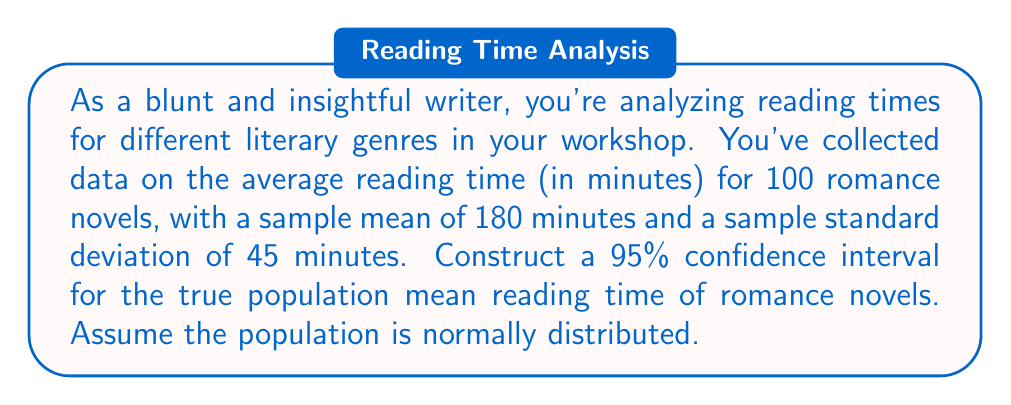Show me your answer to this math problem. To construct a confidence interval for the population mean, we'll use the t-distribution since we don't know the population standard deviation. Here's the step-by-step process:

1. Identify the given information:
   - Sample size: $n = 100$
   - Sample mean: $\bar{x} = 180$ minutes
   - Sample standard deviation: $s = 45$ minutes
   - Confidence level: 95% (α = 0.05)

2. Calculate the standard error of the mean:
   $SE = \frac{s}{\sqrt{n}} = \frac{45}{\sqrt{100}} = \frac{45}{10} = 4.5$

3. Determine the critical t-value:
   With 95% confidence and df = n - 1 = 99, we use t₀.₀₂₅ = 1.984 (from t-distribution table)

4. Calculate the margin of error:
   $E = t_{\alpha/2} \times SE = 1.984 \times 4.5 = 8.928$

5. Construct the confidence interval:
   $CI = \bar{x} \pm E = 180 \pm 8.928$

Therefore, the 95% confidence interval is (171.072, 188.928) minutes.
Answer: The 95% confidence interval for the true population mean reading time of romance novels is (171.072, 188.928) minutes. 